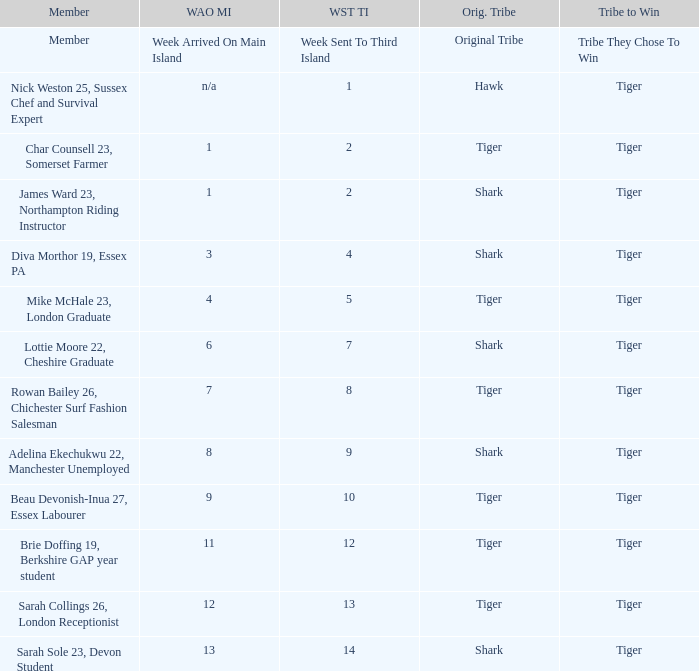What week did the member who's original tribe was shark and who was sent to the third island on week 14 arrive on the main island? 13.0. 